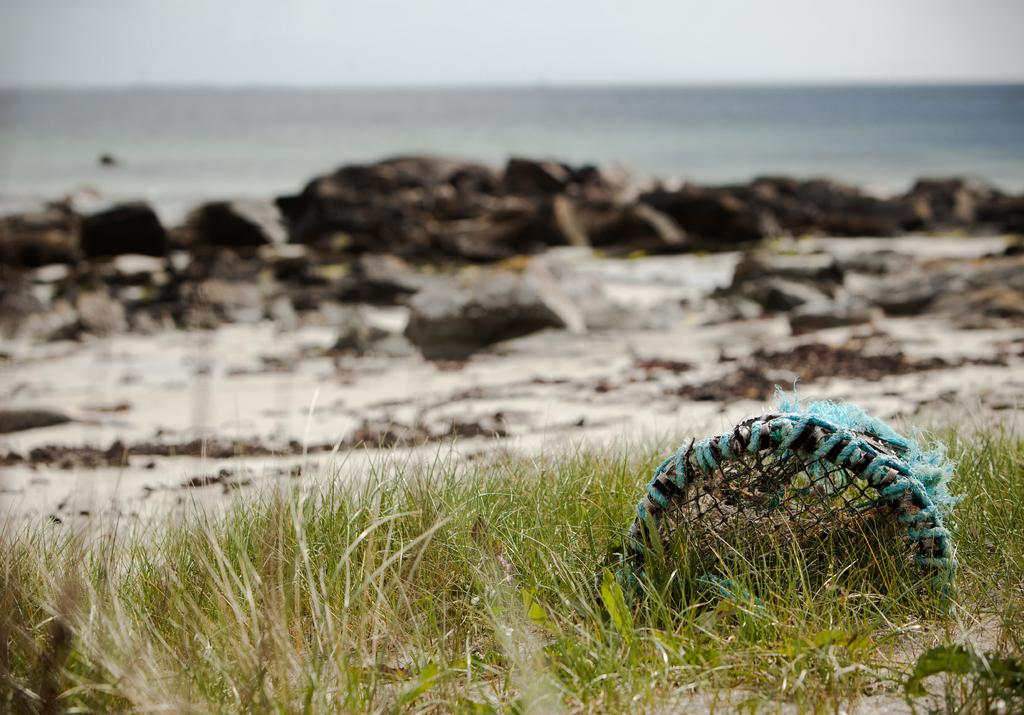What type of terrain is at the bottom of the image? There is grass at the bottom of the image. What object can be seen in the image? There is a basket in the image. What can be seen in the distance in the image? There is water and stones visible in the background of the image. What part of the natural environment is visible in the image? The sky is visible in the image. What type of error can be seen in the image? There is no error present in the image. How many roses are visible in the image? There are no roses present in the image. 